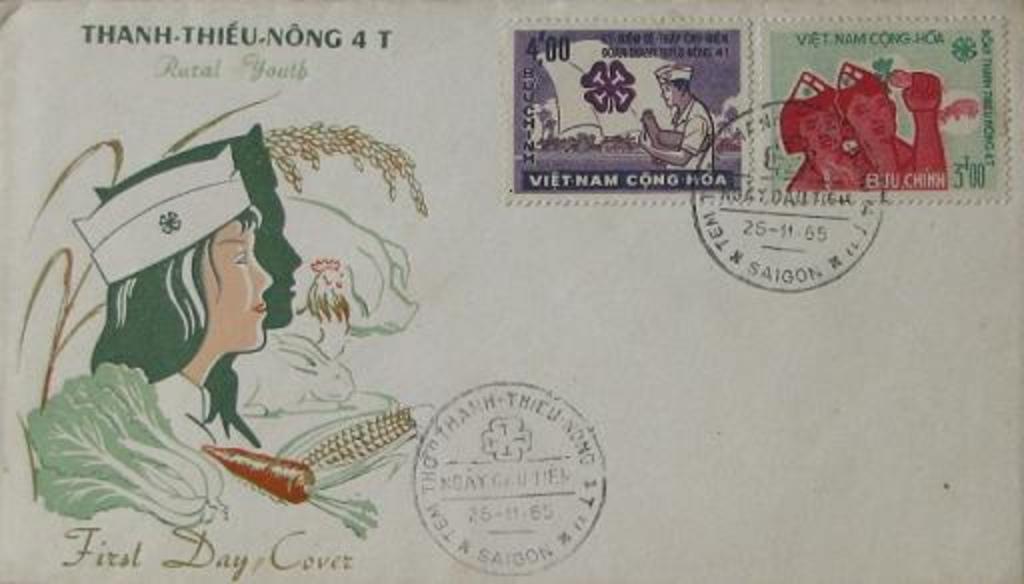Where is this letter from?
Provide a succinct answer. Vietnam. 